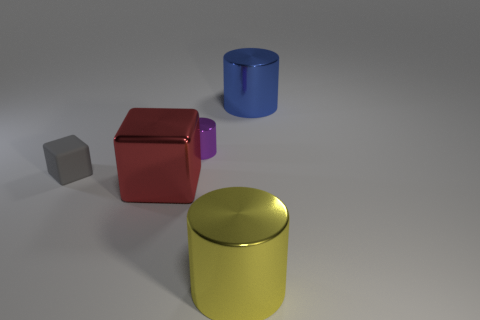What number of other things are the same shape as the blue shiny object?
Your response must be concise. 2. Is the number of gray objects that are behind the blue shiny object less than the number of yellow cylinders?
Your answer should be compact. Yes. There is a large cylinder that is in front of the gray rubber block; what is its material?
Give a very brief answer. Metal. What number of other things are there of the same size as the matte object?
Your answer should be very brief. 1. Are there fewer tiny metallic things than big blue rubber spheres?
Your response must be concise. No. The small purple metallic object has what shape?
Your answer should be compact. Cylinder. There is a big metal cylinder that is in front of the purple cylinder; is it the same color as the tiny metal object?
Provide a succinct answer. No. What shape is the big shiny object that is to the right of the red metallic thing and in front of the tiny rubber block?
Keep it short and to the point. Cylinder. What is the color of the block that is to the left of the red cube?
Offer a terse response. Gray. Are there any other things that have the same color as the tiny metal cylinder?
Provide a short and direct response. No. 